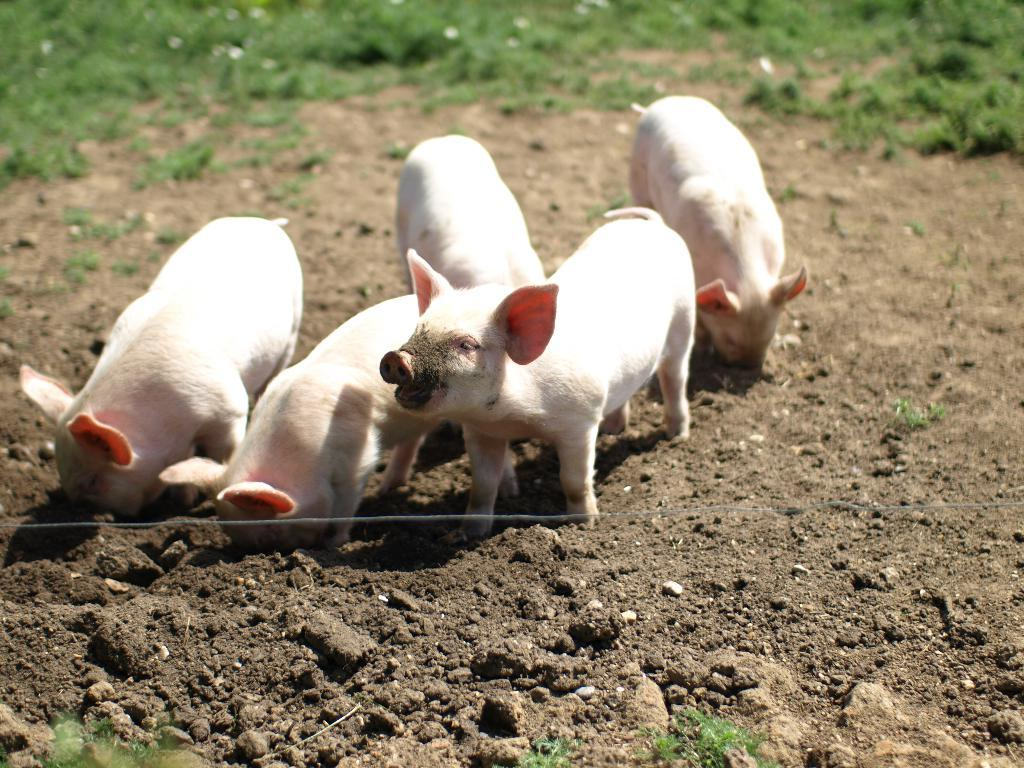What animals are on the sand in the image? There are pigs on the surface of the sand. What type of vegetation can be seen in the background of the image? There is grass visible in the background of the image. What type of dinner is being served to the bear in the image? There is no bear or dinner present in the image; it features pigs on the sand and grass in the background. 